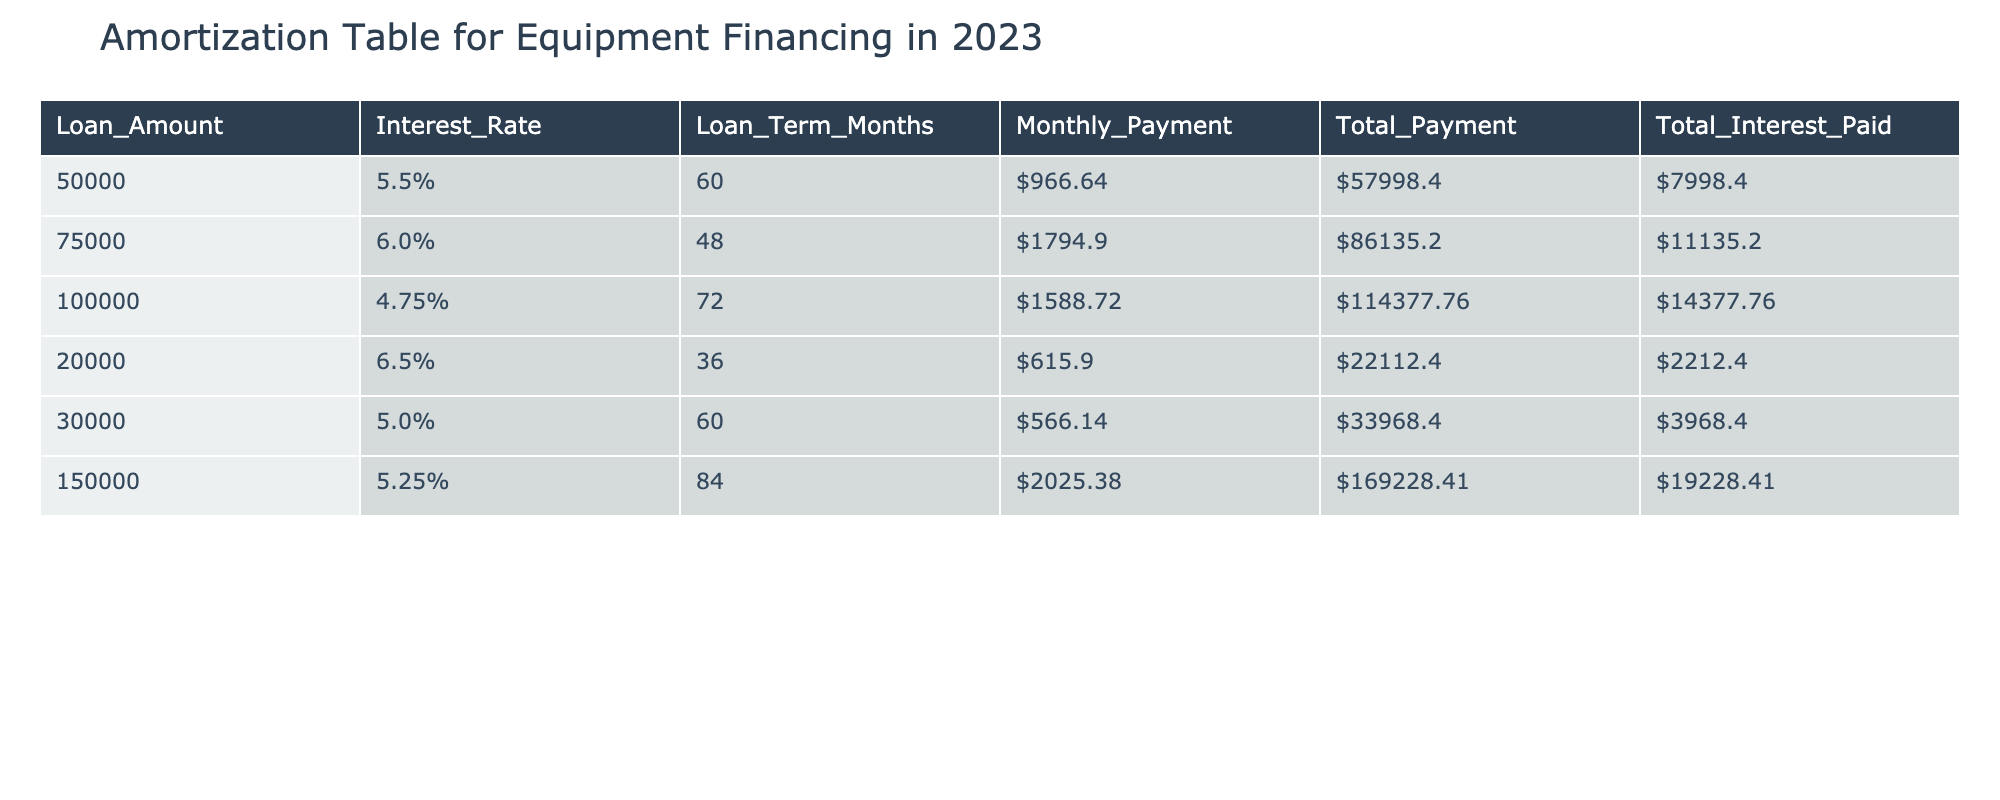What is the loan amount for the equipment that has a total interest paid of 7998.40? By inspecting the table, we can find the row where the total interest paid is 7998.40. This value corresponds to the loan amount of 50000 in the same row.
Answer: 50000 Which loan has the highest total payment? In the table, we can look at the total payment column and identify the maximum value. The highest total payment listed is 169228.41, which corresponds to the loan amount of 150000.
Answer: 150000 What is the monthly payment for a loan of 75000? We can find the row that corresponds to the loan amount of 75000 and observe the monthly payment value in that row. It is stated as 1794.90.
Answer: 1794.90 Is the interest rate for the loan amount of 20000 higher than that for the loan amount of 30000? Comparing the interest rates in the table, the interest rate for the loan amount of 20000 is 6.5%, while the interest rate for 30000 is 5.0%. Since 6.5% is greater than 5.0%, the statement is true.
Answer: Yes What is the total interest paid for the loan of 100000 compared to the loan of 150000? To answer this, we need to look at the total interest paid for both loans: 100000 has a total interest of 14377.76, while 150000 has a total interest of 19228.41. Now, we subtract: 19228.41 - 14377.76 = 4849.65. This means the loan of 150000 has 4849.65 more interest paid than the loan of 100000.
Answer: 4849.65 What is the average monthly payment for all loans listed? To find the average, we need to sum the monthly payments: 966.64 + 1794.90 + 1588.72 + 615.90 + 566.14 + 2025.38 = 6157.68. Then, divide this by the number of loans, which is 6: 6157.68 / 6 = 1026.28. Therefore, the average monthly payment is 1026.28.
Answer: 1026.28 Is the total payment for the loan of 30000 greater than the sum of total payments for the loans of 20000 and 50000? First, we find the total payment for the loan of 30000, which is 33968.40. Next, we sum the total payments for loans of 20000 (22112.40) and 50000 (57998.40) = 80110.80. Since 33968.40 is less than 80110.80, the statement is false.
Answer: No How much total interest is paid across all loans combined? We need to sum all the total interest paid: 7998.40 + 11135.20 + 14377.76 + 2212.40 + 3968.40 + 19228.41 = 64620.57. Therefore, the total interest paid across all loans is 64620.57.
Answer: 64620.57 